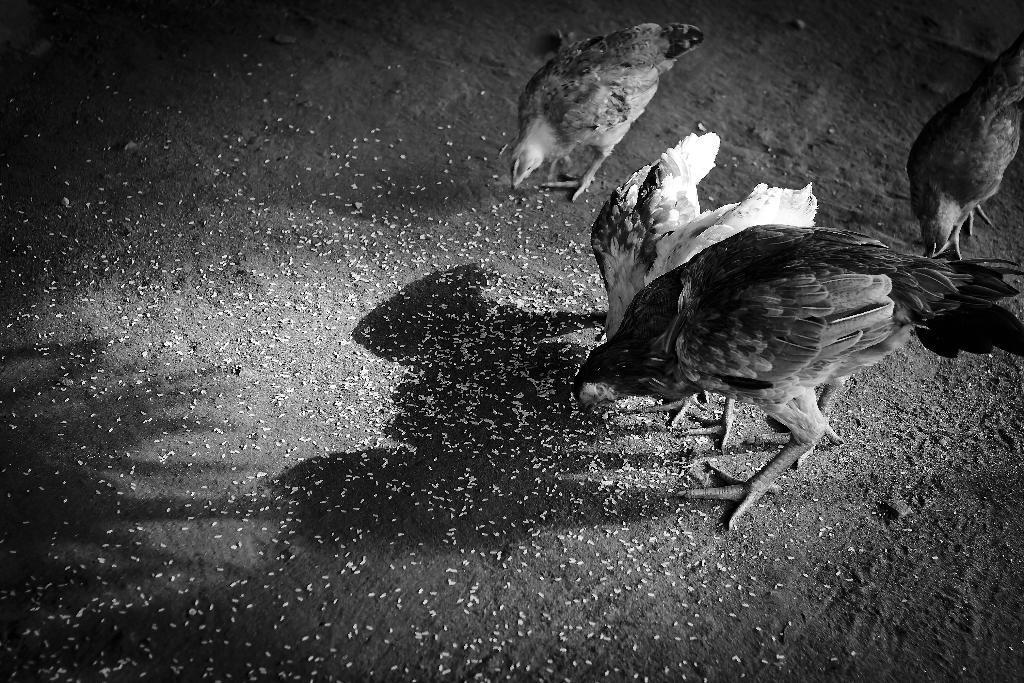Can you describe this image briefly? This is a black and white image. In this image we can see hens eating food grains on the ground. 